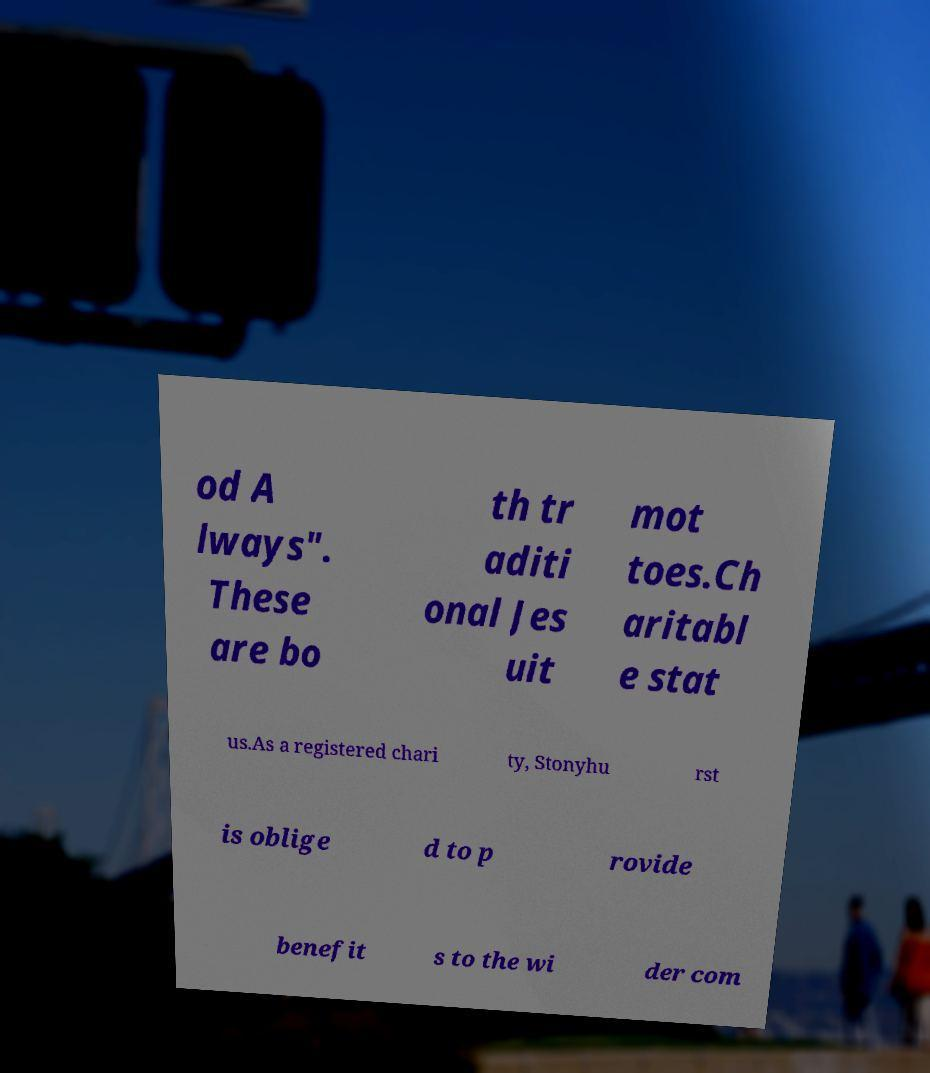Could you extract and type out the text from this image? od A lways". These are bo th tr aditi onal Jes uit mot toes.Ch aritabl e stat us.As a registered chari ty, Stonyhu rst is oblige d to p rovide benefit s to the wi der com 